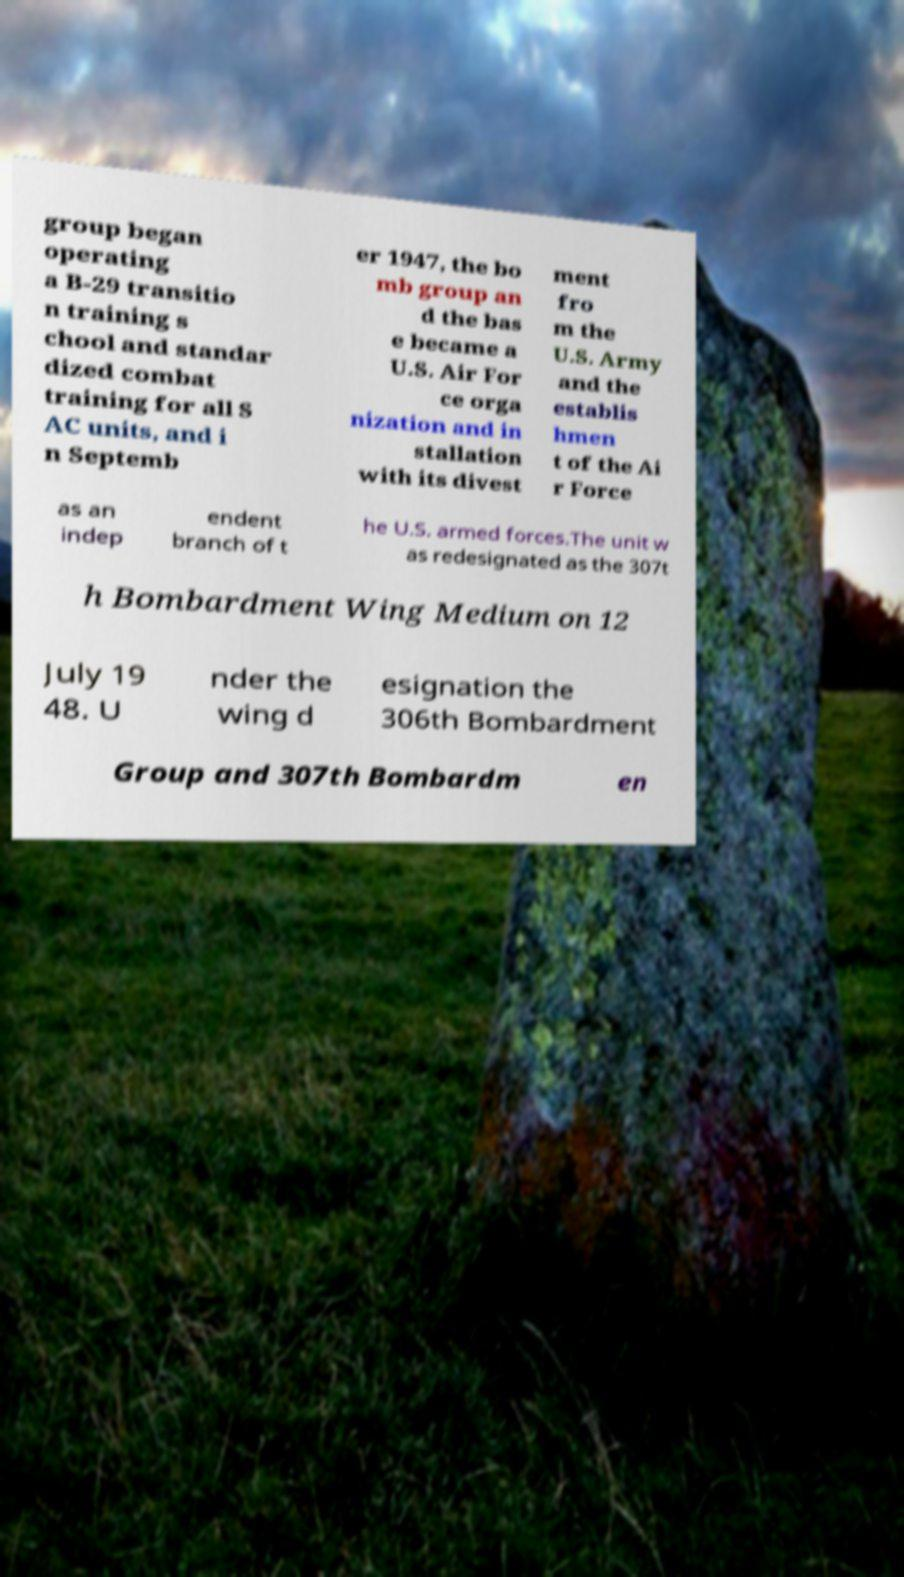Please identify and transcribe the text found in this image. group began operating a B-29 transitio n training s chool and standar dized combat training for all S AC units, and i n Septemb er 1947, the bo mb group an d the bas e became a U.S. Air For ce orga nization and in stallation with its divest ment fro m the U.S. Army and the establis hmen t of the Ai r Force as an indep endent branch of t he U.S. armed forces.The unit w as redesignated as the 307t h Bombardment Wing Medium on 12 July 19 48. U nder the wing d esignation the 306th Bombardment Group and 307th Bombardm en 